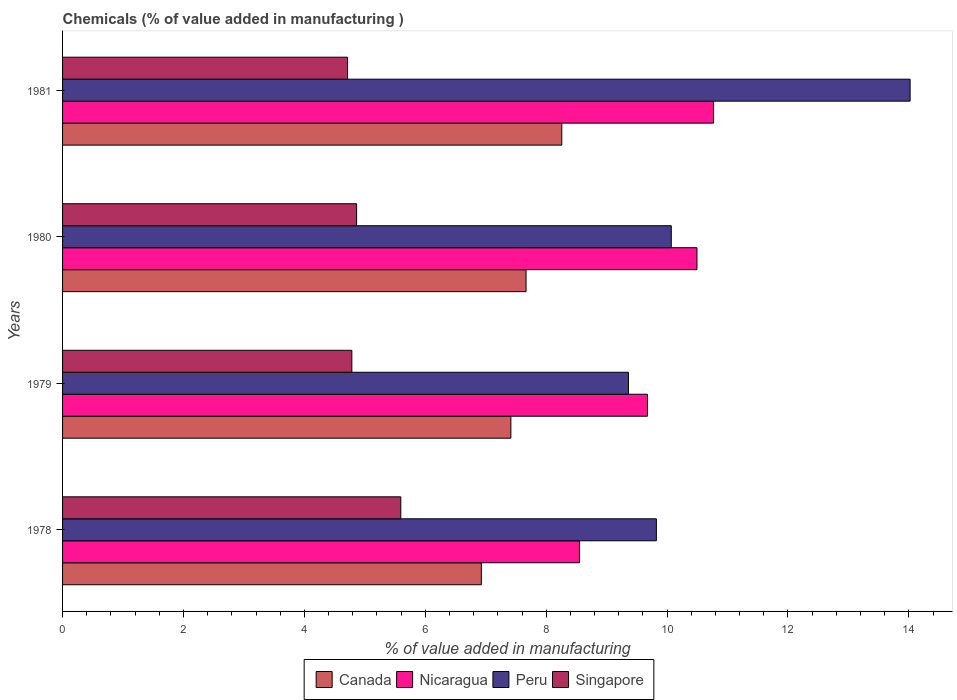How many groups of bars are there?
Your response must be concise. 4. How many bars are there on the 3rd tick from the bottom?
Your response must be concise. 4. What is the label of the 4th group of bars from the top?
Ensure brevity in your answer.  1978. What is the value added in manufacturing chemicals in Peru in 1980?
Offer a terse response. 10.07. Across all years, what is the maximum value added in manufacturing chemicals in Canada?
Give a very brief answer. 8.26. Across all years, what is the minimum value added in manufacturing chemicals in Peru?
Offer a terse response. 9.36. In which year was the value added in manufacturing chemicals in Nicaragua minimum?
Your response must be concise. 1978. What is the total value added in manufacturing chemicals in Peru in the graph?
Make the answer very short. 43.27. What is the difference between the value added in manufacturing chemicals in Singapore in 1978 and that in 1980?
Make the answer very short. 0.73. What is the difference between the value added in manufacturing chemicals in Nicaragua in 1981 and the value added in manufacturing chemicals in Singapore in 1980?
Ensure brevity in your answer.  5.91. What is the average value added in manufacturing chemicals in Peru per year?
Give a very brief answer. 10.82. In the year 1981, what is the difference between the value added in manufacturing chemicals in Canada and value added in manufacturing chemicals in Singapore?
Give a very brief answer. 3.54. In how many years, is the value added in manufacturing chemicals in Nicaragua greater than 4 %?
Offer a terse response. 4. What is the ratio of the value added in manufacturing chemicals in Peru in 1980 to that in 1981?
Provide a succinct answer. 0.72. What is the difference between the highest and the second highest value added in manufacturing chemicals in Peru?
Make the answer very short. 3.95. What is the difference between the highest and the lowest value added in manufacturing chemicals in Singapore?
Your answer should be very brief. 0.88. Is it the case that in every year, the sum of the value added in manufacturing chemicals in Nicaragua and value added in manufacturing chemicals in Singapore is greater than the sum of value added in manufacturing chemicals in Canada and value added in manufacturing chemicals in Peru?
Provide a succinct answer. Yes. What does the 1st bar from the top in 1980 represents?
Keep it short and to the point. Singapore. What does the 4th bar from the bottom in 1979 represents?
Ensure brevity in your answer.  Singapore. Are the values on the major ticks of X-axis written in scientific E-notation?
Ensure brevity in your answer.  No. Does the graph contain any zero values?
Your response must be concise. No. Where does the legend appear in the graph?
Your response must be concise. Bottom center. How many legend labels are there?
Your answer should be very brief. 4. What is the title of the graph?
Your answer should be very brief. Chemicals (% of value added in manufacturing ). Does "Maldives" appear as one of the legend labels in the graph?
Provide a succinct answer. No. What is the label or title of the X-axis?
Offer a terse response. % of value added in manufacturing. What is the label or title of the Y-axis?
Provide a short and direct response. Years. What is the % of value added in manufacturing of Canada in 1978?
Provide a succinct answer. 6.93. What is the % of value added in manufacturing of Nicaragua in 1978?
Offer a terse response. 8.55. What is the % of value added in manufacturing of Peru in 1978?
Make the answer very short. 9.82. What is the % of value added in manufacturing of Singapore in 1978?
Provide a succinct answer. 5.6. What is the % of value added in manufacturing in Canada in 1979?
Offer a terse response. 7.42. What is the % of value added in manufacturing of Nicaragua in 1979?
Ensure brevity in your answer.  9.68. What is the % of value added in manufacturing in Peru in 1979?
Provide a short and direct response. 9.36. What is the % of value added in manufacturing of Singapore in 1979?
Ensure brevity in your answer.  4.79. What is the % of value added in manufacturing of Canada in 1980?
Ensure brevity in your answer.  7.67. What is the % of value added in manufacturing of Nicaragua in 1980?
Offer a terse response. 10.49. What is the % of value added in manufacturing of Peru in 1980?
Your answer should be compact. 10.07. What is the % of value added in manufacturing of Singapore in 1980?
Offer a terse response. 4.86. What is the % of value added in manufacturing of Canada in 1981?
Make the answer very short. 8.26. What is the % of value added in manufacturing of Nicaragua in 1981?
Your response must be concise. 10.77. What is the % of value added in manufacturing in Peru in 1981?
Your answer should be very brief. 14.02. What is the % of value added in manufacturing of Singapore in 1981?
Provide a succinct answer. 4.71. Across all years, what is the maximum % of value added in manufacturing of Canada?
Provide a succinct answer. 8.26. Across all years, what is the maximum % of value added in manufacturing in Nicaragua?
Your answer should be compact. 10.77. Across all years, what is the maximum % of value added in manufacturing of Peru?
Your answer should be compact. 14.02. Across all years, what is the maximum % of value added in manufacturing in Singapore?
Ensure brevity in your answer.  5.6. Across all years, what is the minimum % of value added in manufacturing of Canada?
Keep it short and to the point. 6.93. Across all years, what is the minimum % of value added in manufacturing of Nicaragua?
Ensure brevity in your answer.  8.55. Across all years, what is the minimum % of value added in manufacturing of Peru?
Offer a very short reply. 9.36. Across all years, what is the minimum % of value added in manufacturing of Singapore?
Make the answer very short. 4.71. What is the total % of value added in manufacturing of Canada in the graph?
Offer a very short reply. 30.27. What is the total % of value added in manufacturing in Nicaragua in the graph?
Your response must be concise. 39.49. What is the total % of value added in manufacturing of Peru in the graph?
Provide a short and direct response. 43.27. What is the total % of value added in manufacturing of Singapore in the graph?
Ensure brevity in your answer.  19.96. What is the difference between the % of value added in manufacturing in Canada in 1978 and that in 1979?
Your answer should be compact. -0.49. What is the difference between the % of value added in manufacturing in Nicaragua in 1978 and that in 1979?
Ensure brevity in your answer.  -1.12. What is the difference between the % of value added in manufacturing in Peru in 1978 and that in 1979?
Make the answer very short. 0.46. What is the difference between the % of value added in manufacturing of Singapore in 1978 and that in 1979?
Give a very brief answer. 0.81. What is the difference between the % of value added in manufacturing in Canada in 1978 and that in 1980?
Offer a very short reply. -0.74. What is the difference between the % of value added in manufacturing in Nicaragua in 1978 and that in 1980?
Your response must be concise. -1.94. What is the difference between the % of value added in manufacturing in Peru in 1978 and that in 1980?
Provide a succinct answer. -0.25. What is the difference between the % of value added in manufacturing of Singapore in 1978 and that in 1980?
Ensure brevity in your answer.  0.73. What is the difference between the % of value added in manufacturing in Canada in 1978 and that in 1981?
Ensure brevity in your answer.  -1.33. What is the difference between the % of value added in manufacturing of Nicaragua in 1978 and that in 1981?
Your answer should be very brief. -2.22. What is the difference between the % of value added in manufacturing of Peru in 1978 and that in 1981?
Your answer should be compact. -4.2. What is the difference between the % of value added in manufacturing in Singapore in 1978 and that in 1981?
Offer a terse response. 0.88. What is the difference between the % of value added in manufacturing in Canada in 1979 and that in 1980?
Ensure brevity in your answer.  -0.25. What is the difference between the % of value added in manufacturing of Nicaragua in 1979 and that in 1980?
Provide a short and direct response. -0.82. What is the difference between the % of value added in manufacturing of Peru in 1979 and that in 1980?
Provide a short and direct response. -0.71. What is the difference between the % of value added in manufacturing in Singapore in 1979 and that in 1980?
Your answer should be compact. -0.08. What is the difference between the % of value added in manufacturing of Canada in 1979 and that in 1981?
Your response must be concise. -0.84. What is the difference between the % of value added in manufacturing in Nicaragua in 1979 and that in 1981?
Ensure brevity in your answer.  -1.09. What is the difference between the % of value added in manufacturing in Peru in 1979 and that in 1981?
Make the answer very short. -4.66. What is the difference between the % of value added in manufacturing in Singapore in 1979 and that in 1981?
Provide a succinct answer. 0.07. What is the difference between the % of value added in manufacturing in Canada in 1980 and that in 1981?
Your answer should be very brief. -0.59. What is the difference between the % of value added in manufacturing of Nicaragua in 1980 and that in 1981?
Keep it short and to the point. -0.27. What is the difference between the % of value added in manufacturing of Peru in 1980 and that in 1981?
Keep it short and to the point. -3.95. What is the difference between the % of value added in manufacturing of Singapore in 1980 and that in 1981?
Your response must be concise. 0.15. What is the difference between the % of value added in manufacturing in Canada in 1978 and the % of value added in manufacturing in Nicaragua in 1979?
Make the answer very short. -2.75. What is the difference between the % of value added in manufacturing in Canada in 1978 and the % of value added in manufacturing in Peru in 1979?
Make the answer very short. -2.43. What is the difference between the % of value added in manufacturing of Canada in 1978 and the % of value added in manufacturing of Singapore in 1979?
Provide a short and direct response. 2.14. What is the difference between the % of value added in manufacturing of Nicaragua in 1978 and the % of value added in manufacturing of Peru in 1979?
Provide a succinct answer. -0.81. What is the difference between the % of value added in manufacturing of Nicaragua in 1978 and the % of value added in manufacturing of Singapore in 1979?
Your answer should be compact. 3.77. What is the difference between the % of value added in manufacturing in Peru in 1978 and the % of value added in manufacturing in Singapore in 1979?
Ensure brevity in your answer.  5.04. What is the difference between the % of value added in manufacturing of Canada in 1978 and the % of value added in manufacturing of Nicaragua in 1980?
Keep it short and to the point. -3.57. What is the difference between the % of value added in manufacturing of Canada in 1978 and the % of value added in manufacturing of Peru in 1980?
Your response must be concise. -3.14. What is the difference between the % of value added in manufacturing of Canada in 1978 and the % of value added in manufacturing of Singapore in 1980?
Provide a succinct answer. 2.06. What is the difference between the % of value added in manufacturing of Nicaragua in 1978 and the % of value added in manufacturing of Peru in 1980?
Provide a succinct answer. -1.52. What is the difference between the % of value added in manufacturing in Nicaragua in 1978 and the % of value added in manufacturing in Singapore in 1980?
Your response must be concise. 3.69. What is the difference between the % of value added in manufacturing of Peru in 1978 and the % of value added in manufacturing of Singapore in 1980?
Offer a terse response. 4.96. What is the difference between the % of value added in manufacturing in Canada in 1978 and the % of value added in manufacturing in Nicaragua in 1981?
Offer a terse response. -3.84. What is the difference between the % of value added in manufacturing in Canada in 1978 and the % of value added in manufacturing in Peru in 1981?
Your answer should be compact. -7.09. What is the difference between the % of value added in manufacturing in Canada in 1978 and the % of value added in manufacturing in Singapore in 1981?
Make the answer very short. 2.21. What is the difference between the % of value added in manufacturing of Nicaragua in 1978 and the % of value added in manufacturing of Peru in 1981?
Your answer should be compact. -5.47. What is the difference between the % of value added in manufacturing of Nicaragua in 1978 and the % of value added in manufacturing of Singapore in 1981?
Ensure brevity in your answer.  3.84. What is the difference between the % of value added in manufacturing of Peru in 1978 and the % of value added in manufacturing of Singapore in 1981?
Offer a very short reply. 5.11. What is the difference between the % of value added in manufacturing of Canada in 1979 and the % of value added in manufacturing of Nicaragua in 1980?
Provide a short and direct response. -3.08. What is the difference between the % of value added in manufacturing of Canada in 1979 and the % of value added in manufacturing of Peru in 1980?
Offer a very short reply. -2.65. What is the difference between the % of value added in manufacturing of Canada in 1979 and the % of value added in manufacturing of Singapore in 1980?
Give a very brief answer. 2.55. What is the difference between the % of value added in manufacturing of Nicaragua in 1979 and the % of value added in manufacturing of Peru in 1980?
Keep it short and to the point. -0.39. What is the difference between the % of value added in manufacturing of Nicaragua in 1979 and the % of value added in manufacturing of Singapore in 1980?
Give a very brief answer. 4.81. What is the difference between the % of value added in manufacturing of Peru in 1979 and the % of value added in manufacturing of Singapore in 1980?
Your answer should be compact. 4.5. What is the difference between the % of value added in manufacturing of Canada in 1979 and the % of value added in manufacturing of Nicaragua in 1981?
Keep it short and to the point. -3.35. What is the difference between the % of value added in manufacturing in Canada in 1979 and the % of value added in manufacturing in Peru in 1981?
Provide a succinct answer. -6.6. What is the difference between the % of value added in manufacturing in Canada in 1979 and the % of value added in manufacturing in Singapore in 1981?
Your answer should be compact. 2.7. What is the difference between the % of value added in manufacturing in Nicaragua in 1979 and the % of value added in manufacturing in Peru in 1981?
Ensure brevity in your answer.  -4.34. What is the difference between the % of value added in manufacturing in Nicaragua in 1979 and the % of value added in manufacturing in Singapore in 1981?
Your response must be concise. 4.96. What is the difference between the % of value added in manufacturing in Peru in 1979 and the % of value added in manufacturing in Singapore in 1981?
Offer a very short reply. 4.65. What is the difference between the % of value added in manufacturing in Canada in 1980 and the % of value added in manufacturing in Nicaragua in 1981?
Ensure brevity in your answer.  -3.1. What is the difference between the % of value added in manufacturing in Canada in 1980 and the % of value added in manufacturing in Peru in 1981?
Make the answer very short. -6.35. What is the difference between the % of value added in manufacturing of Canada in 1980 and the % of value added in manufacturing of Singapore in 1981?
Offer a very short reply. 2.95. What is the difference between the % of value added in manufacturing in Nicaragua in 1980 and the % of value added in manufacturing in Peru in 1981?
Provide a succinct answer. -3.53. What is the difference between the % of value added in manufacturing in Nicaragua in 1980 and the % of value added in manufacturing in Singapore in 1981?
Offer a very short reply. 5.78. What is the difference between the % of value added in manufacturing of Peru in 1980 and the % of value added in manufacturing of Singapore in 1981?
Provide a succinct answer. 5.35. What is the average % of value added in manufacturing in Canada per year?
Offer a very short reply. 7.57. What is the average % of value added in manufacturing in Nicaragua per year?
Provide a succinct answer. 9.87. What is the average % of value added in manufacturing of Peru per year?
Offer a terse response. 10.82. What is the average % of value added in manufacturing of Singapore per year?
Make the answer very short. 4.99. In the year 1978, what is the difference between the % of value added in manufacturing of Canada and % of value added in manufacturing of Nicaragua?
Provide a succinct answer. -1.62. In the year 1978, what is the difference between the % of value added in manufacturing of Canada and % of value added in manufacturing of Peru?
Your answer should be compact. -2.9. In the year 1978, what is the difference between the % of value added in manufacturing in Canada and % of value added in manufacturing in Singapore?
Provide a short and direct response. 1.33. In the year 1978, what is the difference between the % of value added in manufacturing of Nicaragua and % of value added in manufacturing of Peru?
Keep it short and to the point. -1.27. In the year 1978, what is the difference between the % of value added in manufacturing in Nicaragua and % of value added in manufacturing in Singapore?
Provide a succinct answer. 2.96. In the year 1978, what is the difference between the % of value added in manufacturing in Peru and % of value added in manufacturing in Singapore?
Your response must be concise. 4.23. In the year 1979, what is the difference between the % of value added in manufacturing in Canada and % of value added in manufacturing in Nicaragua?
Keep it short and to the point. -2.26. In the year 1979, what is the difference between the % of value added in manufacturing of Canada and % of value added in manufacturing of Peru?
Ensure brevity in your answer.  -1.94. In the year 1979, what is the difference between the % of value added in manufacturing in Canada and % of value added in manufacturing in Singapore?
Your response must be concise. 2.63. In the year 1979, what is the difference between the % of value added in manufacturing of Nicaragua and % of value added in manufacturing of Peru?
Offer a terse response. 0.31. In the year 1979, what is the difference between the % of value added in manufacturing of Nicaragua and % of value added in manufacturing of Singapore?
Your response must be concise. 4.89. In the year 1979, what is the difference between the % of value added in manufacturing of Peru and % of value added in manufacturing of Singapore?
Make the answer very short. 4.58. In the year 1980, what is the difference between the % of value added in manufacturing in Canada and % of value added in manufacturing in Nicaragua?
Keep it short and to the point. -2.83. In the year 1980, what is the difference between the % of value added in manufacturing of Canada and % of value added in manufacturing of Peru?
Offer a very short reply. -2.4. In the year 1980, what is the difference between the % of value added in manufacturing of Canada and % of value added in manufacturing of Singapore?
Make the answer very short. 2.8. In the year 1980, what is the difference between the % of value added in manufacturing in Nicaragua and % of value added in manufacturing in Peru?
Your answer should be compact. 0.42. In the year 1980, what is the difference between the % of value added in manufacturing of Nicaragua and % of value added in manufacturing of Singapore?
Make the answer very short. 5.63. In the year 1980, what is the difference between the % of value added in manufacturing of Peru and % of value added in manufacturing of Singapore?
Give a very brief answer. 5.21. In the year 1981, what is the difference between the % of value added in manufacturing of Canada and % of value added in manufacturing of Nicaragua?
Your answer should be compact. -2.51. In the year 1981, what is the difference between the % of value added in manufacturing in Canada and % of value added in manufacturing in Peru?
Offer a very short reply. -5.76. In the year 1981, what is the difference between the % of value added in manufacturing in Canada and % of value added in manufacturing in Singapore?
Your answer should be very brief. 3.54. In the year 1981, what is the difference between the % of value added in manufacturing in Nicaragua and % of value added in manufacturing in Peru?
Your answer should be very brief. -3.25. In the year 1981, what is the difference between the % of value added in manufacturing of Nicaragua and % of value added in manufacturing of Singapore?
Your answer should be compact. 6.05. In the year 1981, what is the difference between the % of value added in manufacturing in Peru and % of value added in manufacturing in Singapore?
Make the answer very short. 9.31. What is the ratio of the % of value added in manufacturing in Canada in 1978 to that in 1979?
Make the answer very short. 0.93. What is the ratio of the % of value added in manufacturing in Nicaragua in 1978 to that in 1979?
Offer a terse response. 0.88. What is the ratio of the % of value added in manufacturing in Peru in 1978 to that in 1979?
Provide a short and direct response. 1.05. What is the ratio of the % of value added in manufacturing of Singapore in 1978 to that in 1979?
Offer a terse response. 1.17. What is the ratio of the % of value added in manufacturing of Canada in 1978 to that in 1980?
Provide a succinct answer. 0.9. What is the ratio of the % of value added in manufacturing in Nicaragua in 1978 to that in 1980?
Make the answer very short. 0.81. What is the ratio of the % of value added in manufacturing of Peru in 1978 to that in 1980?
Provide a short and direct response. 0.98. What is the ratio of the % of value added in manufacturing of Singapore in 1978 to that in 1980?
Make the answer very short. 1.15. What is the ratio of the % of value added in manufacturing of Canada in 1978 to that in 1981?
Give a very brief answer. 0.84. What is the ratio of the % of value added in manufacturing in Nicaragua in 1978 to that in 1981?
Provide a succinct answer. 0.79. What is the ratio of the % of value added in manufacturing of Peru in 1978 to that in 1981?
Offer a terse response. 0.7. What is the ratio of the % of value added in manufacturing of Singapore in 1978 to that in 1981?
Make the answer very short. 1.19. What is the ratio of the % of value added in manufacturing of Canada in 1979 to that in 1980?
Give a very brief answer. 0.97. What is the ratio of the % of value added in manufacturing in Nicaragua in 1979 to that in 1980?
Offer a very short reply. 0.92. What is the ratio of the % of value added in manufacturing in Peru in 1979 to that in 1980?
Make the answer very short. 0.93. What is the ratio of the % of value added in manufacturing of Singapore in 1979 to that in 1980?
Your response must be concise. 0.98. What is the ratio of the % of value added in manufacturing in Canada in 1979 to that in 1981?
Provide a succinct answer. 0.9. What is the ratio of the % of value added in manufacturing in Nicaragua in 1979 to that in 1981?
Your response must be concise. 0.9. What is the ratio of the % of value added in manufacturing in Peru in 1979 to that in 1981?
Your answer should be compact. 0.67. What is the ratio of the % of value added in manufacturing of Canada in 1980 to that in 1981?
Keep it short and to the point. 0.93. What is the ratio of the % of value added in manufacturing in Nicaragua in 1980 to that in 1981?
Your answer should be compact. 0.97. What is the ratio of the % of value added in manufacturing in Peru in 1980 to that in 1981?
Your answer should be very brief. 0.72. What is the ratio of the % of value added in manufacturing in Singapore in 1980 to that in 1981?
Give a very brief answer. 1.03. What is the difference between the highest and the second highest % of value added in manufacturing of Canada?
Offer a terse response. 0.59. What is the difference between the highest and the second highest % of value added in manufacturing of Nicaragua?
Make the answer very short. 0.27. What is the difference between the highest and the second highest % of value added in manufacturing in Peru?
Ensure brevity in your answer.  3.95. What is the difference between the highest and the second highest % of value added in manufacturing of Singapore?
Provide a short and direct response. 0.73. What is the difference between the highest and the lowest % of value added in manufacturing in Canada?
Keep it short and to the point. 1.33. What is the difference between the highest and the lowest % of value added in manufacturing of Nicaragua?
Provide a short and direct response. 2.22. What is the difference between the highest and the lowest % of value added in manufacturing of Peru?
Give a very brief answer. 4.66. What is the difference between the highest and the lowest % of value added in manufacturing in Singapore?
Keep it short and to the point. 0.88. 